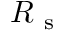Convert formula to latex. <formula><loc_0><loc_0><loc_500><loc_500>R _ { s }</formula> 